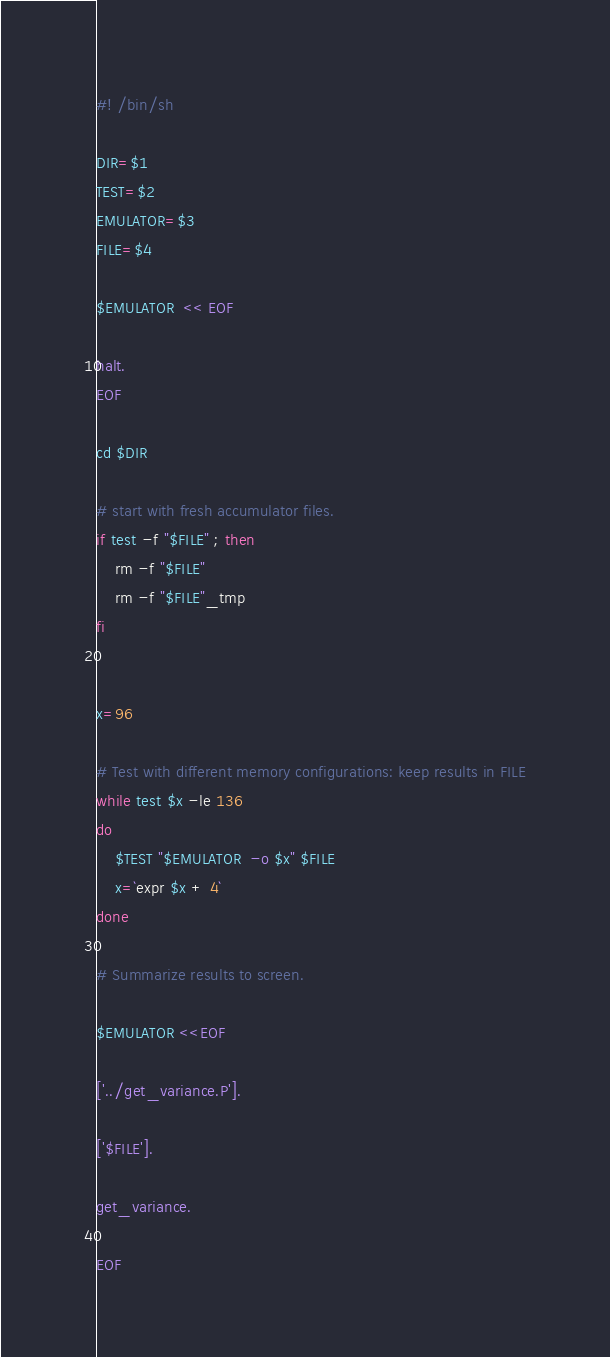Convert code to text. <code><loc_0><loc_0><loc_500><loc_500><_Bash_>#! /bin/sh

DIR=$1
TEST=$2
EMULATOR=$3
FILE=$4

$EMULATOR  << EOF

halt.
EOF

cd $DIR

# start with fresh accumulator files.
if test -f "$FILE" ; then
    rm -f "$FILE"
    rm -f "$FILE"_tmp
fi


x=96

# Test with different memory configurations: keep results in FILE
while test $x -le 136
do
    $TEST "$EMULATOR  -o $x" $FILE
    x=`expr $x + 4`
done

# Summarize results to screen.

$EMULATOR <<EOF
 
['../get_variance.P'].

['$FILE'].

get_variance.

EOF


</code> 